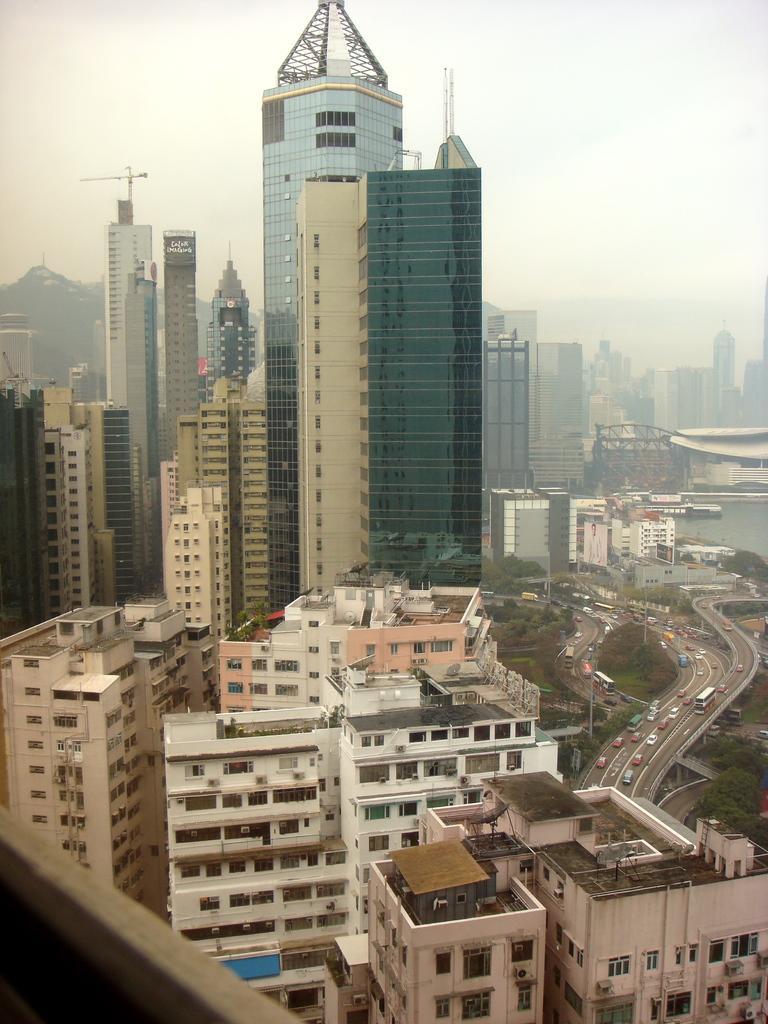Could you give a brief overview of what you see in this image? In this picture we can see a few buildings. There are some trees and vehicles on the road on the right side. 